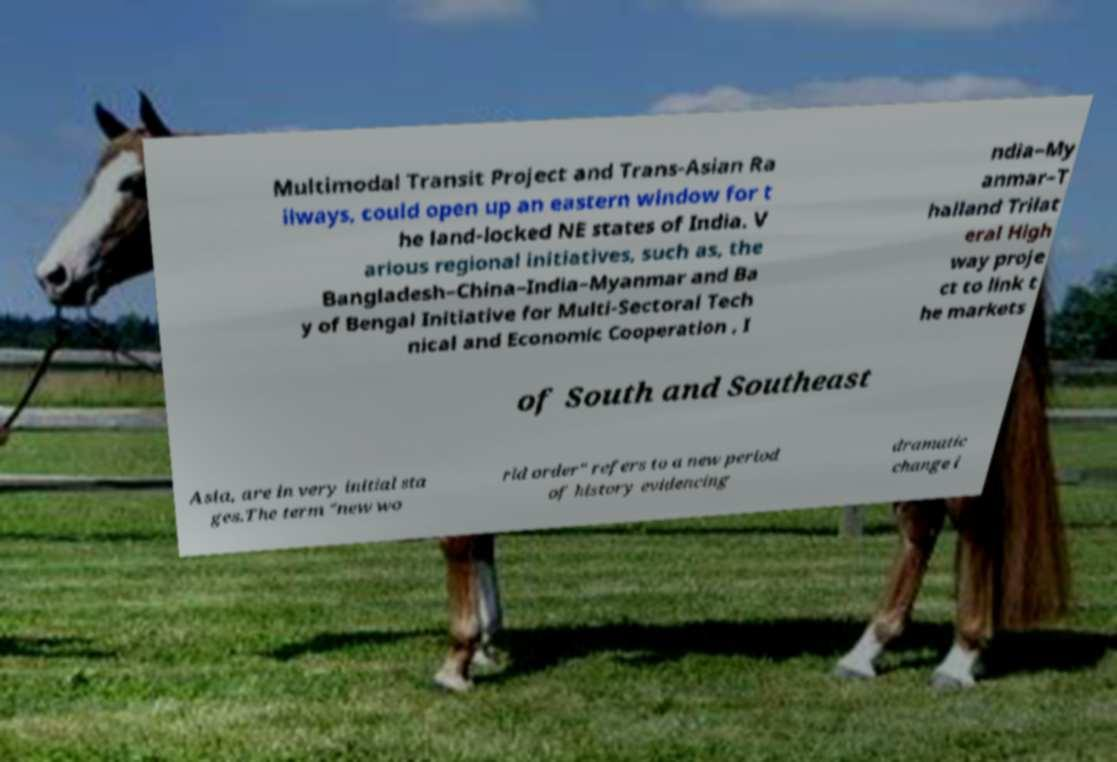For documentation purposes, I need the text within this image transcribed. Could you provide that? Multimodal Transit Project and Trans-Asian Ra ilways, could open up an eastern window for t he land-locked NE states of India. V arious regional initiatives, such as, the Bangladesh–China–India–Myanmar and Ba y of Bengal Initiative for Multi-Sectoral Tech nical and Economic Cooperation , I ndia–My anmar–T hailand Trilat eral High way proje ct to link t he markets of South and Southeast Asia, are in very initial sta ges.The term "new wo rld order" refers to a new period of history evidencing dramatic change i 